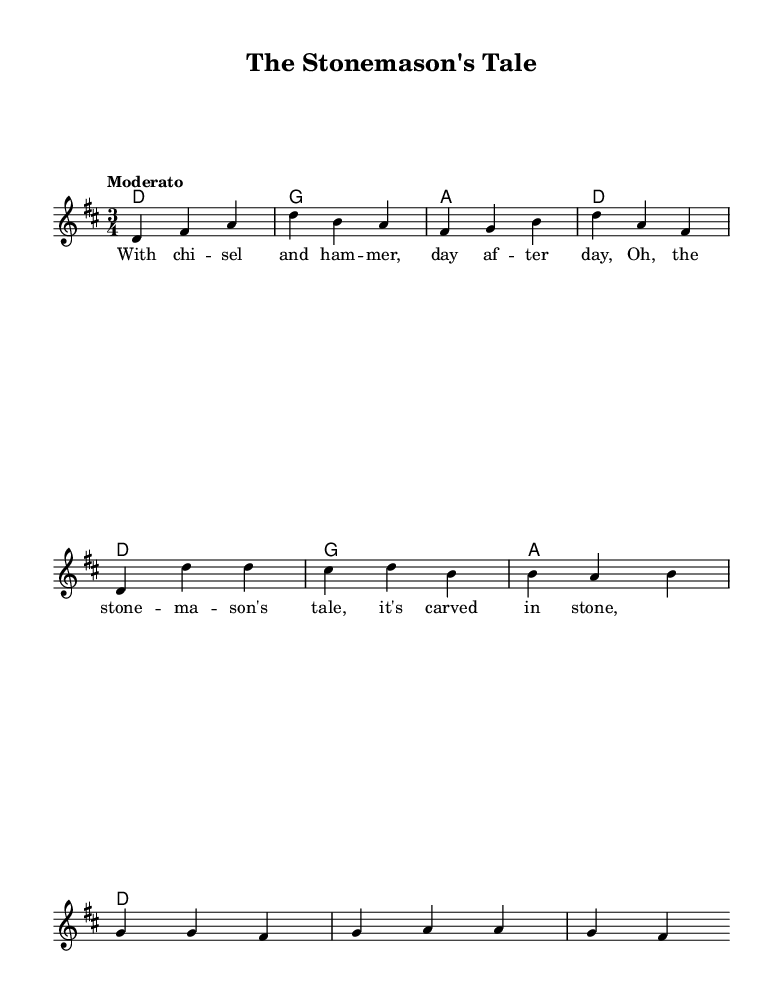What is the key signature of this music? The key signature is D major, which is indicated by two sharps. You can identify the key signature by looking at the beginning of the staff where the sharps are placed.
Answer: D major What is the time signature of this music? The time signature is three-four, as seen at the beginning of the score. It is written as 3/4, indicating three beats per measure with the quarter note getting the beat.
Answer: 3/4 What is the tempo marking of this piece? The tempo marking is "Moderato," which suggests a moderate speed. This is usually indicated below the title and sets the overall mood for the piece.
Answer: Moderato How many measures are there in the verse? There are four measures in the verse section of the music, which can be counted by observing the measure lines in the melody.
Answer: 4 What is the last note of the chorus? The last note of the chorus is "fis." This can be determined by looking at the melody in the chorus section, identifying the notes listed at the end of the measure.
Answer: fis Which instrument is playing the melody? The lead voice is playing the melody, as indicated by the notation that shows "Voice = 'lead'" in the score. This typically represents a melody line in vocal or instrumental music.
Answer: lead What type of song is "The Stonemason's Tale"? "The Stonemason's Tale" is a folk ballad, as indicated in the context of the music and title. Folk ballads often tell stories, particularly of builders and tradesmen as reflected in this piece.
Answer: folk ballad 